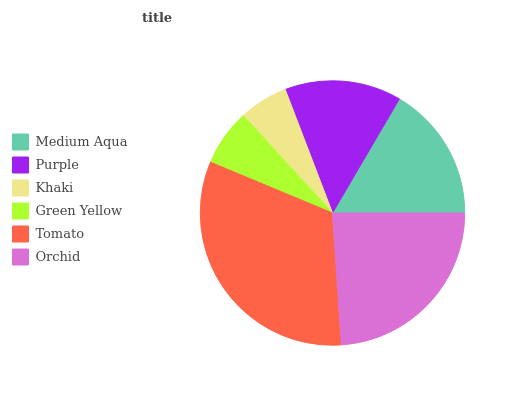Is Khaki the minimum?
Answer yes or no. Yes. Is Tomato the maximum?
Answer yes or no. Yes. Is Purple the minimum?
Answer yes or no. No. Is Purple the maximum?
Answer yes or no. No. Is Medium Aqua greater than Purple?
Answer yes or no. Yes. Is Purple less than Medium Aqua?
Answer yes or no. Yes. Is Purple greater than Medium Aqua?
Answer yes or no. No. Is Medium Aqua less than Purple?
Answer yes or no. No. Is Medium Aqua the high median?
Answer yes or no. Yes. Is Purple the low median?
Answer yes or no. Yes. Is Purple the high median?
Answer yes or no. No. Is Orchid the low median?
Answer yes or no. No. 